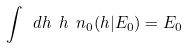Convert formula to latex. <formula><loc_0><loc_0><loc_500><loc_500>\int \ d h \ h \ n _ { 0 } ( h | E _ { 0 } ) = E _ { 0 }</formula> 